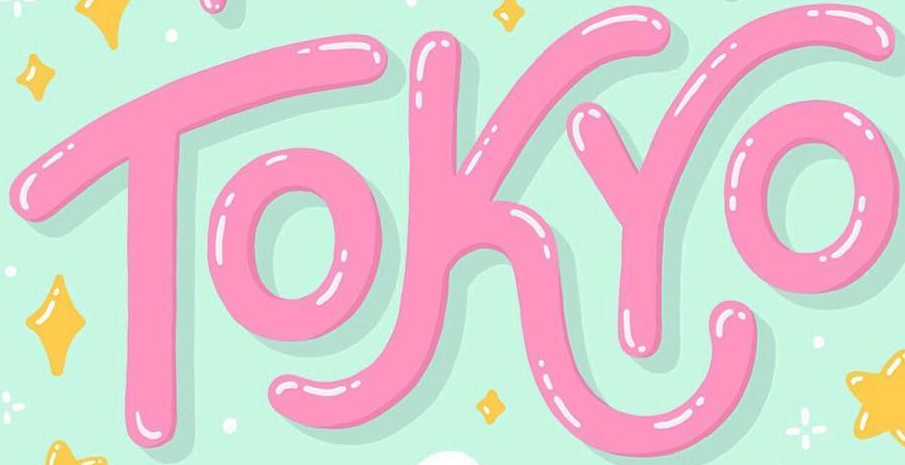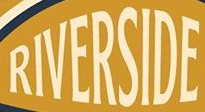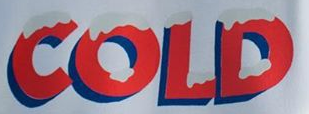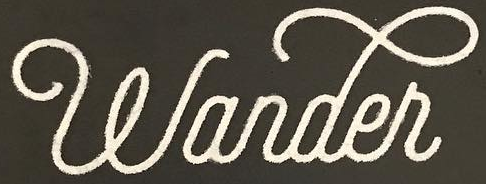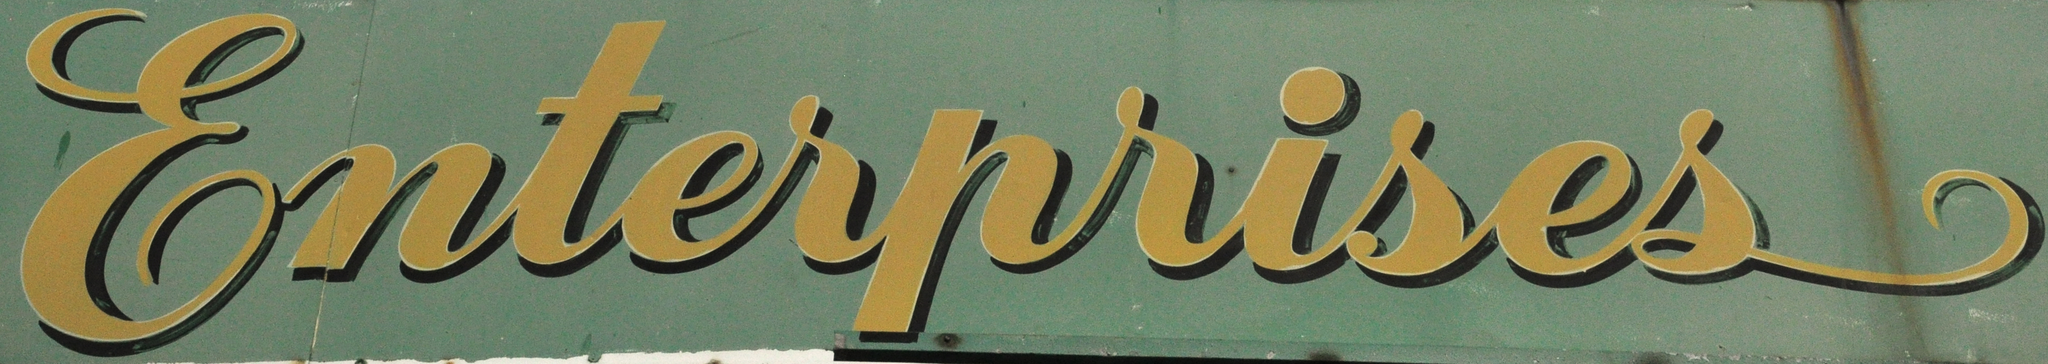Identify the words shown in these images in order, separated by a semicolon. TOKYO; RIVERSIDE; COLD; wander; Enterprises 